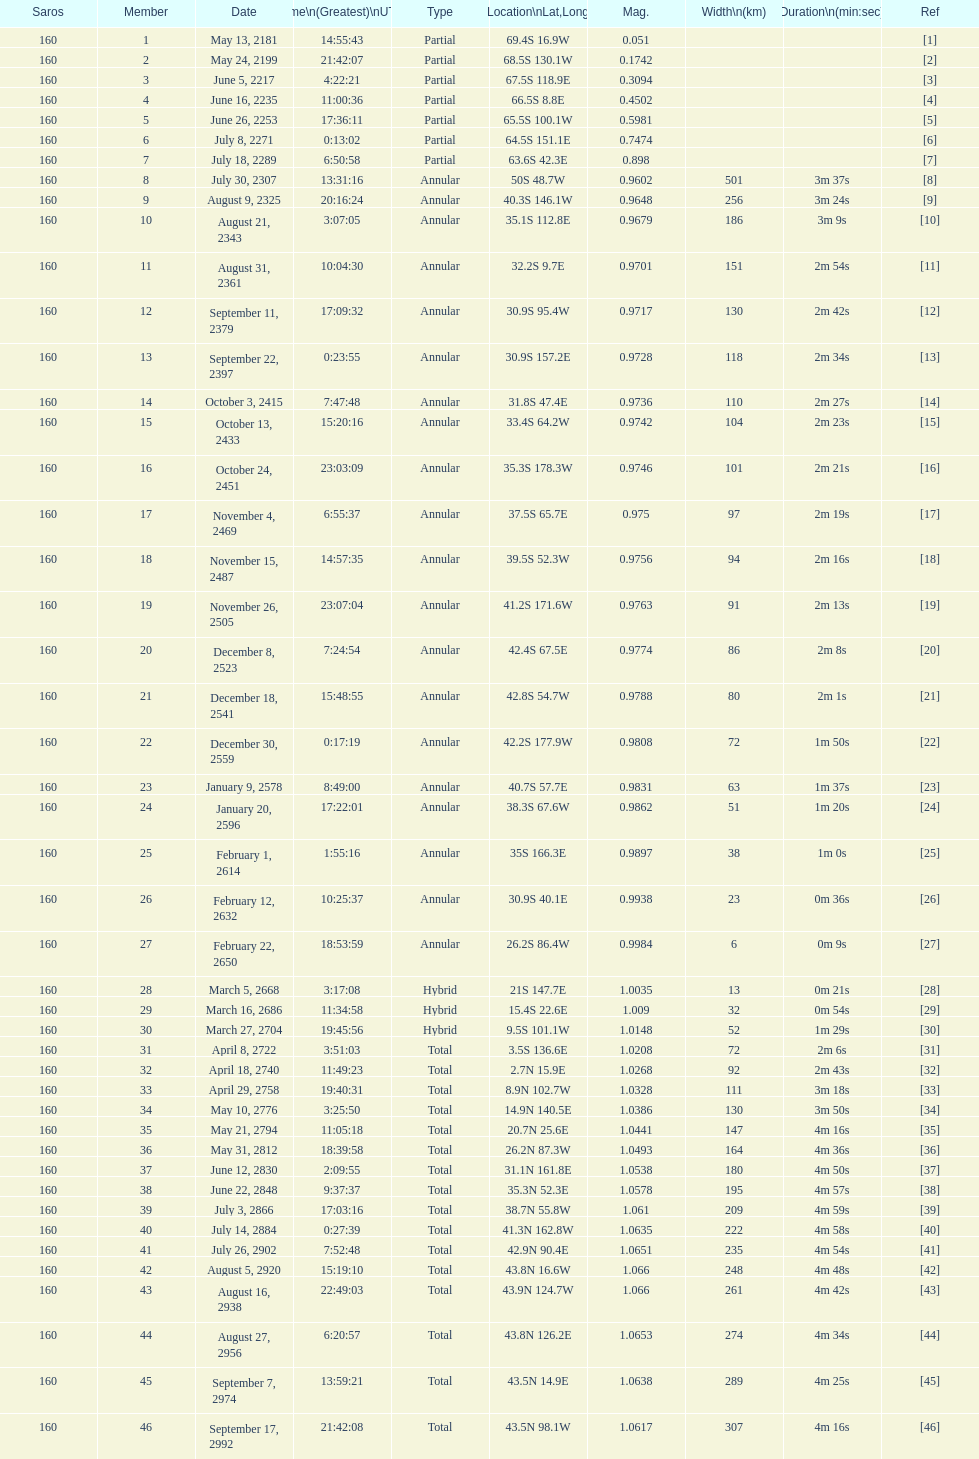What is the previous time for the saros on october 3, 2415? 7:47:48. Could you parse the entire table as a dict? {'header': ['Saros', 'Member', 'Date', 'Time\\n(Greatest)\\nUTC', 'Type', 'Location\\nLat,Long', 'Mag.', 'Width\\n(km)', 'Duration\\n(min:sec)', 'Ref'], 'rows': [['160', '1', 'May 13, 2181', '14:55:43', 'Partial', '69.4S 16.9W', '0.051', '', '', '[1]'], ['160', '2', 'May 24, 2199', '21:42:07', 'Partial', '68.5S 130.1W', '0.1742', '', '', '[2]'], ['160', '3', 'June 5, 2217', '4:22:21', 'Partial', '67.5S 118.9E', '0.3094', '', '', '[3]'], ['160', '4', 'June 16, 2235', '11:00:36', 'Partial', '66.5S 8.8E', '0.4502', '', '', '[4]'], ['160', '5', 'June 26, 2253', '17:36:11', 'Partial', '65.5S 100.1W', '0.5981', '', '', '[5]'], ['160', '6', 'July 8, 2271', '0:13:02', 'Partial', '64.5S 151.1E', '0.7474', '', '', '[6]'], ['160', '7', 'July 18, 2289', '6:50:58', 'Partial', '63.6S 42.3E', '0.898', '', '', '[7]'], ['160', '8', 'July 30, 2307', '13:31:16', 'Annular', '50S 48.7W', '0.9602', '501', '3m 37s', '[8]'], ['160', '9', 'August 9, 2325', '20:16:24', 'Annular', '40.3S 146.1W', '0.9648', '256', '3m 24s', '[9]'], ['160', '10', 'August 21, 2343', '3:07:05', 'Annular', '35.1S 112.8E', '0.9679', '186', '3m 9s', '[10]'], ['160', '11', 'August 31, 2361', '10:04:30', 'Annular', '32.2S 9.7E', '0.9701', '151', '2m 54s', '[11]'], ['160', '12', 'September 11, 2379', '17:09:32', 'Annular', '30.9S 95.4W', '0.9717', '130', '2m 42s', '[12]'], ['160', '13', 'September 22, 2397', '0:23:55', 'Annular', '30.9S 157.2E', '0.9728', '118', '2m 34s', '[13]'], ['160', '14', 'October 3, 2415', '7:47:48', 'Annular', '31.8S 47.4E', '0.9736', '110', '2m 27s', '[14]'], ['160', '15', 'October 13, 2433', '15:20:16', 'Annular', '33.4S 64.2W', '0.9742', '104', '2m 23s', '[15]'], ['160', '16', 'October 24, 2451', '23:03:09', 'Annular', '35.3S 178.3W', '0.9746', '101', '2m 21s', '[16]'], ['160', '17', 'November 4, 2469', '6:55:37', 'Annular', '37.5S 65.7E', '0.975', '97', '2m 19s', '[17]'], ['160', '18', 'November 15, 2487', '14:57:35', 'Annular', '39.5S 52.3W', '0.9756', '94', '2m 16s', '[18]'], ['160', '19', 'November 26, 2505', '23:07:04', 'Annular', '41.2S 171.6W', '0.9763', '91', '2m 13s', '[19]'], ['160', '20', 'December 8, 2523', '7:24:54', 'Annular', '42.4S 67.5E', '0.9774', '86', '2m 8s', '[20]'], ['160', '21', 'December 18, 2541', '15:48:55', 'Annular', '42.8S 54.7W', '0.9788', '80', '2m 1s', '[21]'], ['160', '22', 'December 30, 2559', '0:17:19', 'Annular', '42.2S 177.9W', '0.9808', '72', '1m 50s', '[22]'], ['160', '23', 'January 9, 2578', '8:49:00', 'Annular', '40.7S 57.7E', '0.9831', '63', '1m 37s', '[23]'], ['160', '24', 'January 20, 2596', '17:22:01', 'Annular', '38.3S 67.6W', '0.9862', '51', '1m 20s', '[24]'], ['160', '25', 'February 1, 2614', '1:55:16', 'Annular', '35S 166.3E', '0.9897', '38', '1m 0s', '[25]'], ['160', '26', 'February 12, 2632', '10:25:37', 'Annular', '30.9S 40.1E', '0.9938', '23', '0m 36s', '[26]'], ['160', '27', 'February 22, 2650', '18:53:59', 'Annular', '26.2S 86.4W', '0.9984', '6', '0m 9s', '[27]'], ['160', '28', 'March 5, 2668', '3:17:08', 'Hybrid', '21S 147.7E', '1.0035', '13', '0m 21s', '[28]'], ['160', '29', 'March 16, 2686', '11:34:58', 'Hybrid', '15.4S 22.6E', '1.009', '32', '0m 54s', '[29]'], ['160', '30', 'March 27, 2704', '19:45:56', 'Hybrid', '9.5S 101.1W', '1.0148', '52', '1m 29s', '[30]'], ['160', '31', 'April 8, 2722', '3:51:03', 'Total', '3.5S 136.6E', '1.0208', '72', '2m 6s', '[31]'], ['160', '32', 'April 18, 2740', '11:49:23', 'Total', '2.7N 15.9E', '1.0268', '92', '2m 43s', '[32]'], ['160', '33', 'April 29, 2758', '19:40:31', 'Total', '8.9N 102.7W', '1.0328', '111', '3m 18s', '[33]'], ['160', '34', 'May 10, 2776', '3:25:50', 'Total', '14.9N 140.5E', '1.0386', '130', '3m 50s', '[34]'], ['160', '35', 'May 21, 2794', '11:05:18', 'Total', '20.7N 25.6E', '1.0441', '147', '4m 16s', '[35]'], ['160', '36', 'May 31, 2812', '18:39:58', 'Total', '26.2N 87.3W', '1.0493', '164', '4m 36s', '[36]'], ['160', '37', 'June 12, 2830', '2:09:55', 'Total', '31.1N 161.8E', '1.0538', '180', '4m 50s', '[37]'], ['160', '38', 'June 22, 2848', '9:37:37', 'Total', '35.3N 52.3E', '1.0578', '195', '4m 57s', '[38]'], ['160', '39', 'July 3, 2866', '17:03:16', 'Total', '38.7N 55.8W', '1.061', '209', '4m 59s', '[39]'], ['160', '40', 'July 14, 2884', '0:27:39', 'Total', '41.3N 162.8W', '1.0635', '222', '4m 58s', '[40]'], ['160', '41', 'July 26, 2902', '7:52:48', 'Total', '42.9N 90.4E', '1.0651', '235', '4m 54s', '[41]'], ['160', '42', 'August 5, 2920', '15:19:10', 'Total', '43.8N 16.6W', '1.066', '248', '4m 48s', '[42]'], ['160', '43', 'August 16, 2938', '22:49:03', 'Total', '43.9N 124.7W', '1.066', '261', '4m 42s', '[43]'], ['160', '44', 'August 27, 2956', '6:20:57', 'Total', '43.8N 126.2E', '1.0653', '274', '4m 34s', '[44]'], ['160', '45', 'September 7, 2974', '13:59:21', 'Total', '43.5N 14.9E', '1.0638', '289', '4m 25s', '[45]'], ['160', '46', 'September 17, 2992', '21:42:08', 'Total', '43.5N 98.1W', '1.0617', '307', '4m 16s', '[46]']]} 